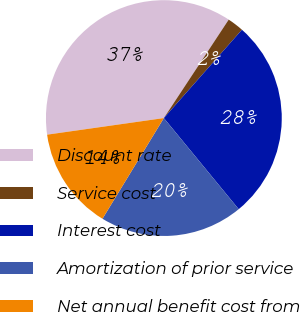Convert chart to OTSL. <chart><loc_0><loc_0><loc_500><loc_500><pie_chart><fcel>Discount rate<fcel>Service cost<fcel>Interest cost<fcel>Amortization of prior service<fcel>Net annual benefit cost from<nl><fcel>36.52%<fcel>2.25%<fcel>27.53%<fcel>19.66%<fcel>14.04%<nl></chart> 